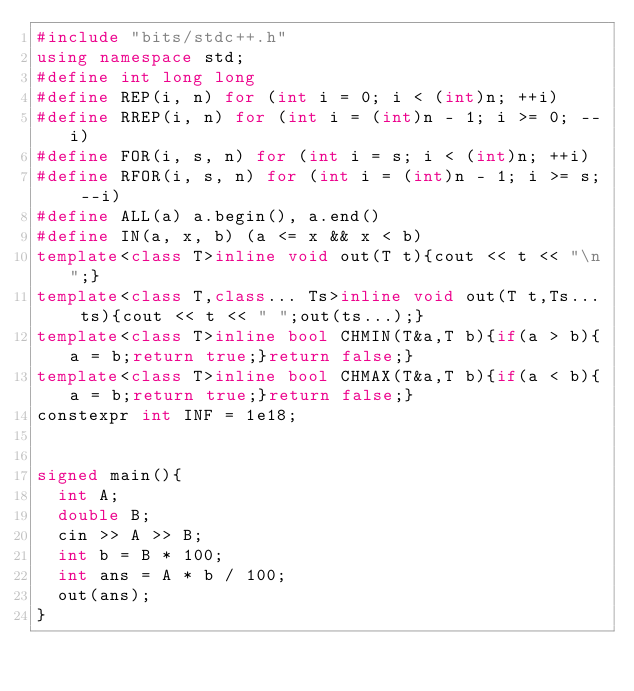Convert code to text. <code><loc_0><loc_0><loc_500><loc_500><_C++_>#include "bits/stdc++.h"
using namespace std;
#define int long long
#define REP(i, n) for (int i = 0; i < (int)n; ++i)
#define RREP(i, n) for (int i = (int)n - 1; i >= 0; --i)
#define FOR(i, s, n) for (int i = s; i < (int)n; ++i)
#define RFOR(i, s, n) for (int i = (int)n - 1; i >= s; --i)
#define ALL(a) a.begin(), a.end()
#define IN(a, x, b) (a <= x && x < b)
template<class T>inline void out(T t){cout << t << "\n";}
template<class T,class... Ts>inline void out(T t,Ts... ts){cout << t << " ";out(ts...);}
template<class T>inline bool CHMIN(T&a,T b){if(a > b){a = b;return true;}return false;}
template<class T>inline bool CHMAX(T&a,T b){if(a < b){a = b;return true;}return false;}
constexpr int INF = 1e18;


signed main(){
	int A;
	double B;
	cin >> A >> B;
	int b = B * 100;
	int ans = A * b / 100;
	out(ans);
}</code> 